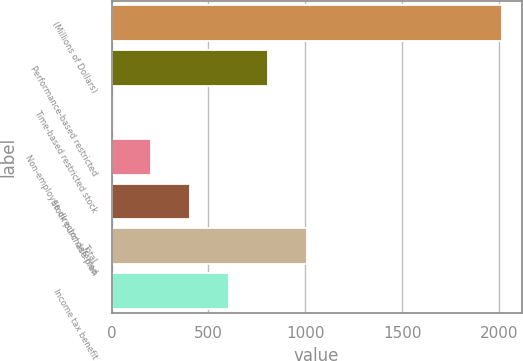Convert chart. <chart><loc_0><loc_0><loc_500><loc_500><bar_chart><fcel>(Millions of Dollars)<fcel>Performance-based restricted<fcel>Time-based restricted stock<fcel>Non-employee director deferred<fcel>Stock purchase plan<fcel>Total<fcel>Income tax benefit<nl><fcel>2014<fcel>806.8<fcel>2<fcel>203.2<fcel>404.4<fcel>1008<fcel>605.6<nl></chart> 